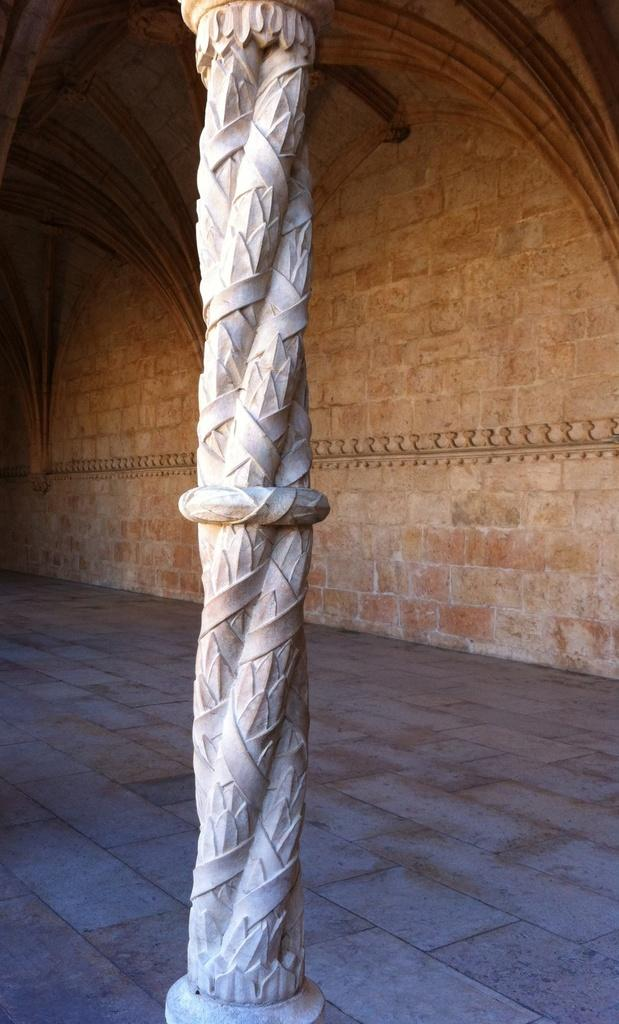What is the main structure visible in the image? There is a pillar in the image. What can be seen behind the pillar? There is a wall in the background of the image. What type of quiver is hanging on the wall in the image? There is no quiver present in the image; it only features a pillar and a wall. 